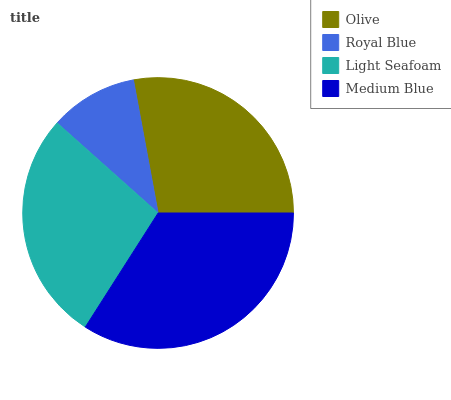Is Royal Blue the minimum?
Answer yes or no. Yes. Is Medium Blue the maximum?
Answer yes or no. Yes. Is Light Seafoam the minimum?
Answer yes or no. No. Is Light Seafoam the maximum?
Answer yes or no. No. Is Light Seafoam greater than Royal Blue?
Answer yes or no. Yes. Is Royal Blue less than Light Seafoam?
Answer yes or no. Yes. Is Royal Blue greater than Light Seafoam?
Answer yes or no. No. Is Light Seafoam less than Royal Blue?
Answer yes or no. No. Is Olive the high median?
Answer yes or no. Yes. Is Light Seafoam the low median?
Answer yes or no. Yes. Is Royal Blue the high median?
Answer yes or no. No. Is Royal Blue the low median?
Answer yes or no. No. 